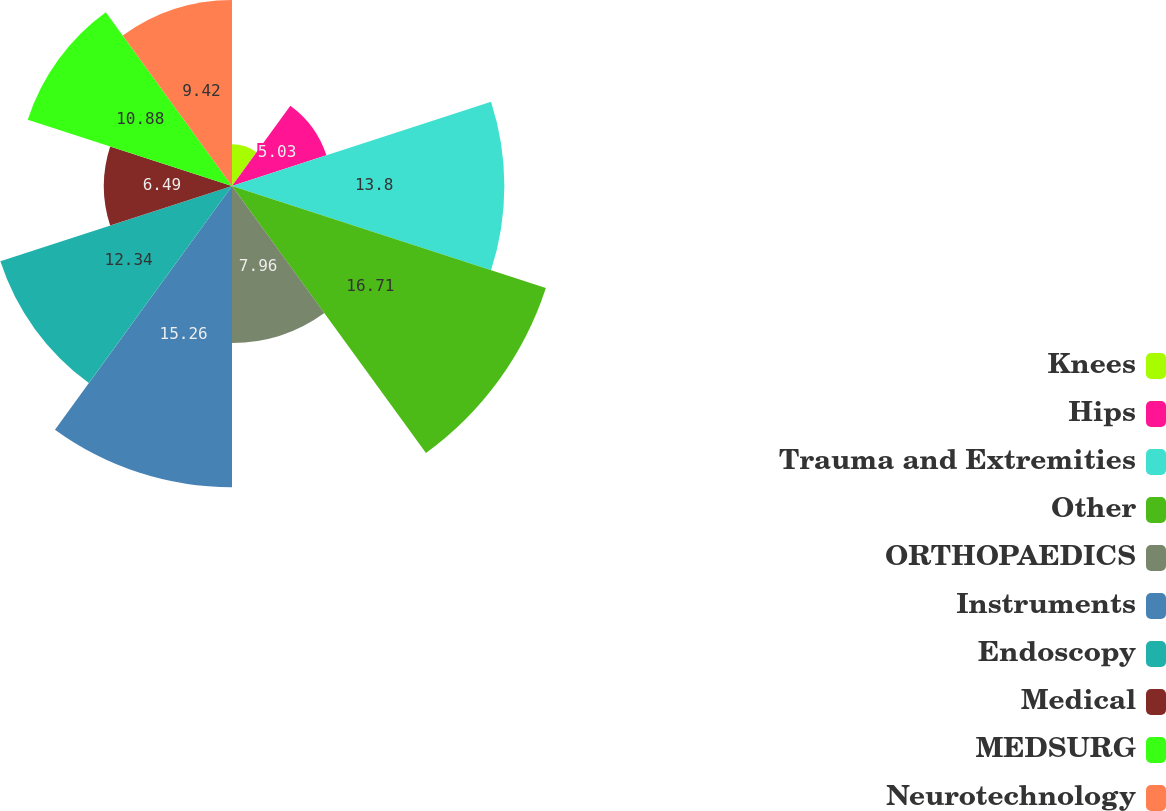Convert chart to OTSL. <chart><loc_0><loc_0><loc_500><loc_500><pie_chart><fcel>Knees<fcel>Hips<fcel>Trauma and Extremities<fcel>Other<fcel>ORTHOPAEDICS<fcel>Instruments<fcel>Endoscopy<fcel>Medical<fcel>MEDSURG<fcel>Neurotechnology<nl><fcel>2.11%<fcel>5.03%<fcel>13.8%<fcel>16.72%<fcel>7.96%<fcel>15.26%<fcel>12.34%<fcel>6.49%<fcel>10.88%<fcel>9.42%<nl></chart> 